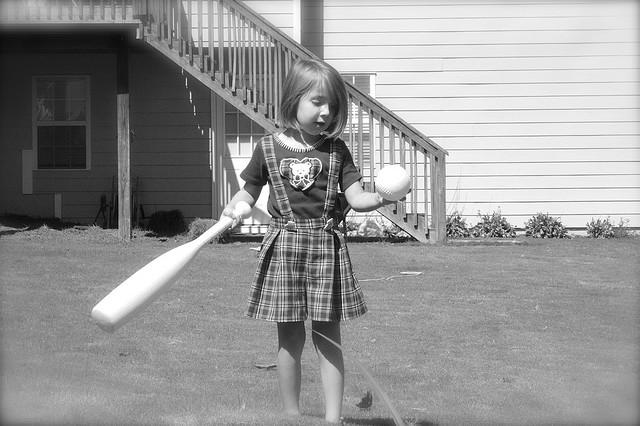What is the little girl doing?
Keep it brief. Playing baseball. What is in the girl's left hand?
Quick response, please. Ball. What does she have in her right hand?
Short answer required. Bat. 